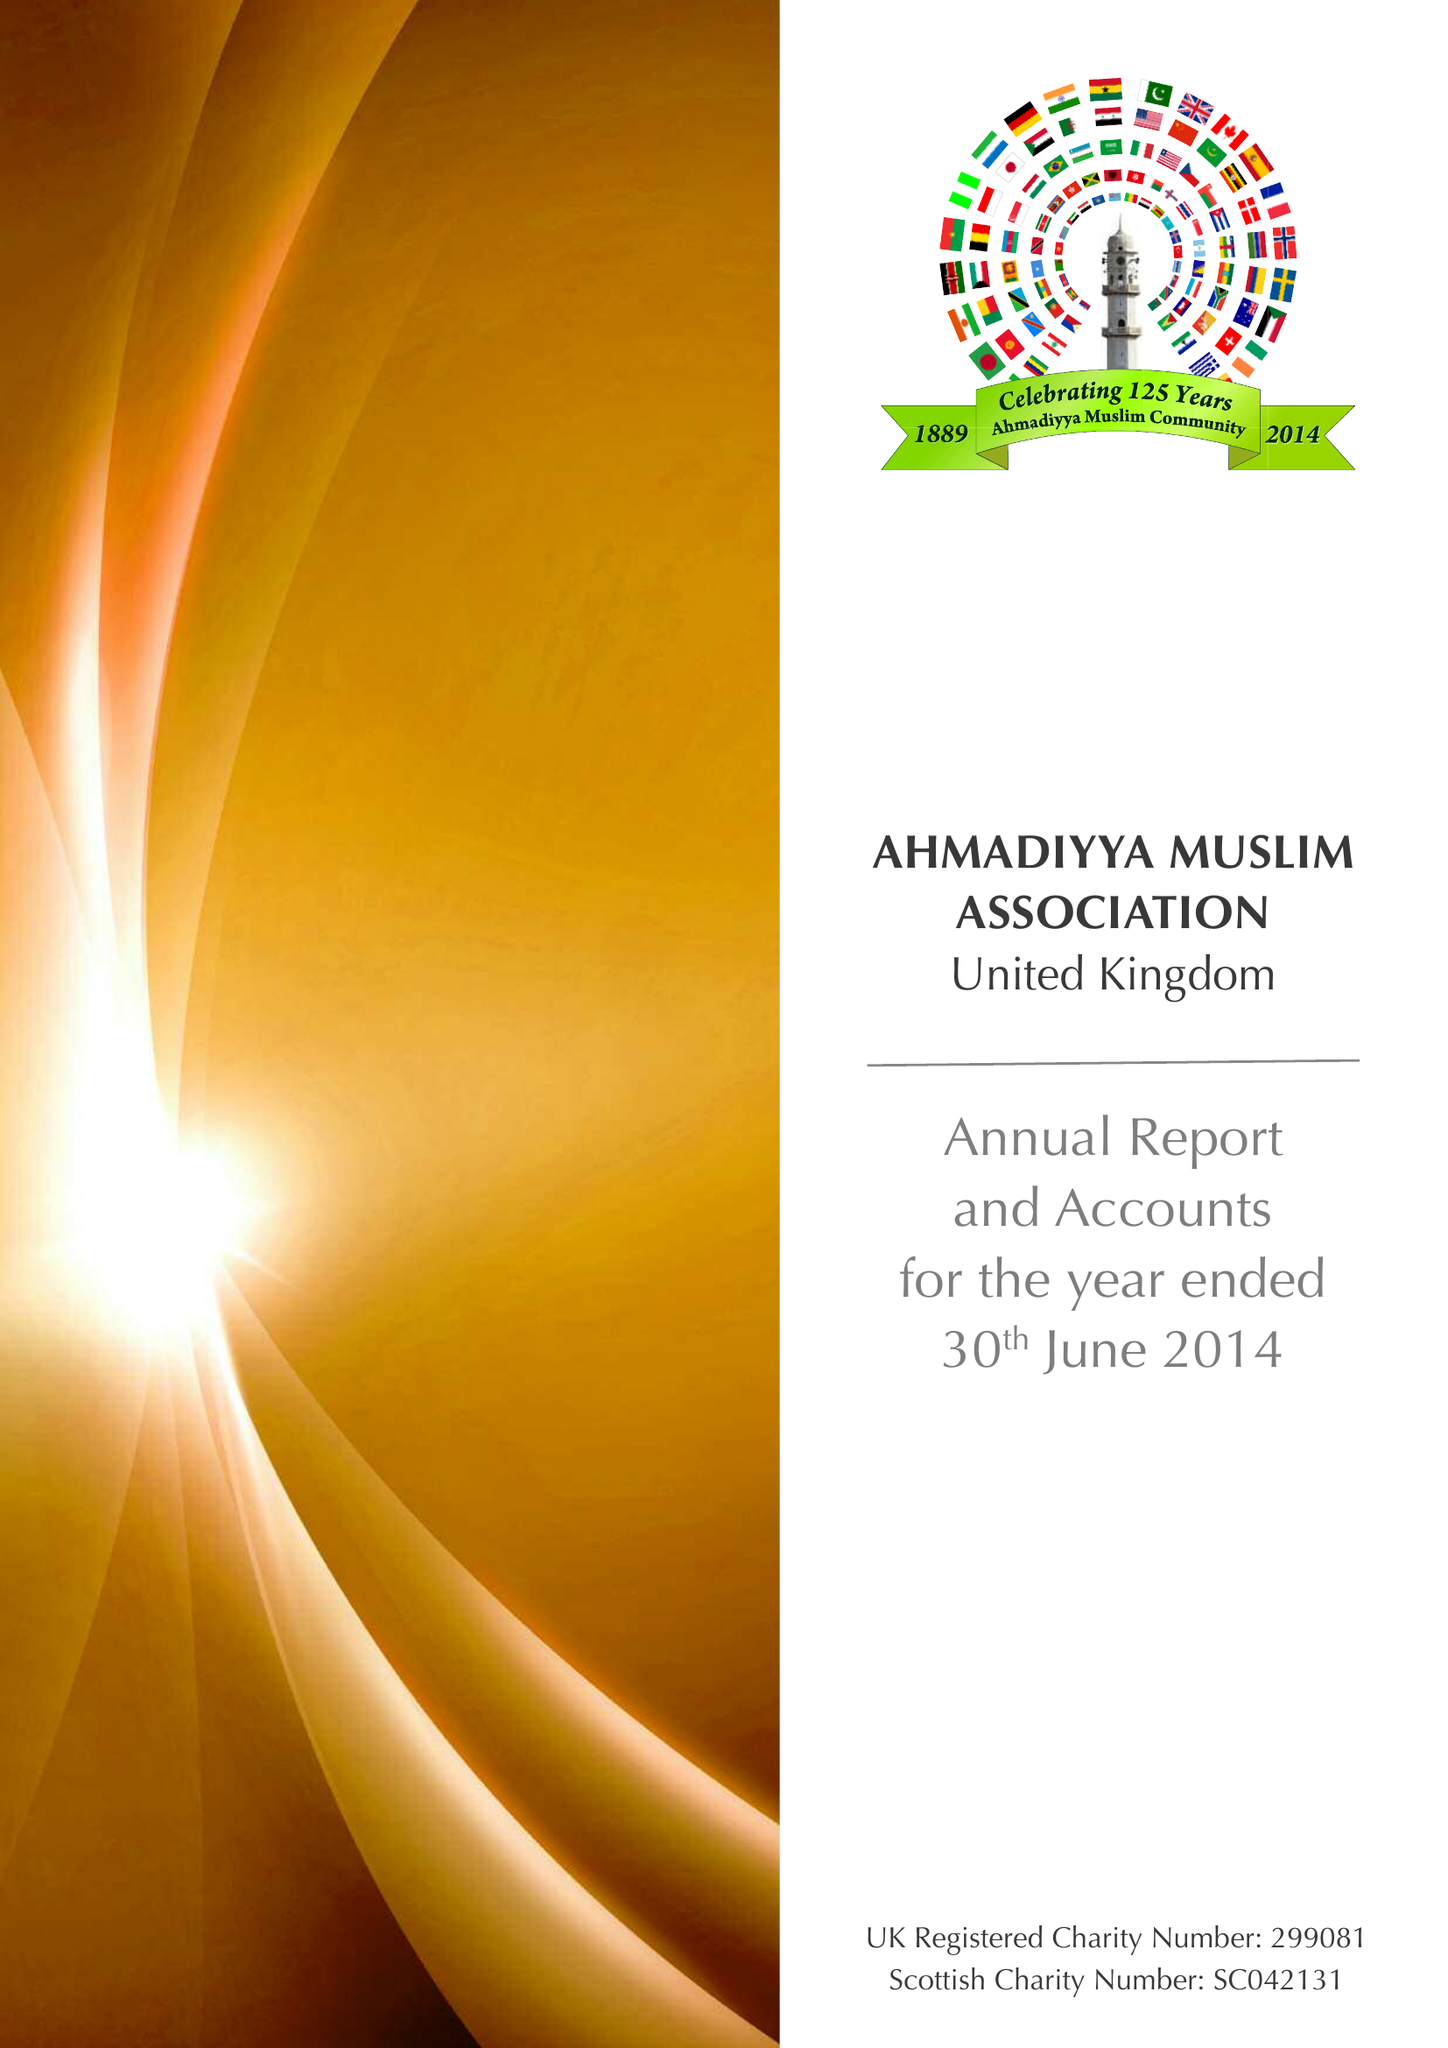What is the value for the report_date?
Answer the question using a single word or phrase. 2014-06-30 